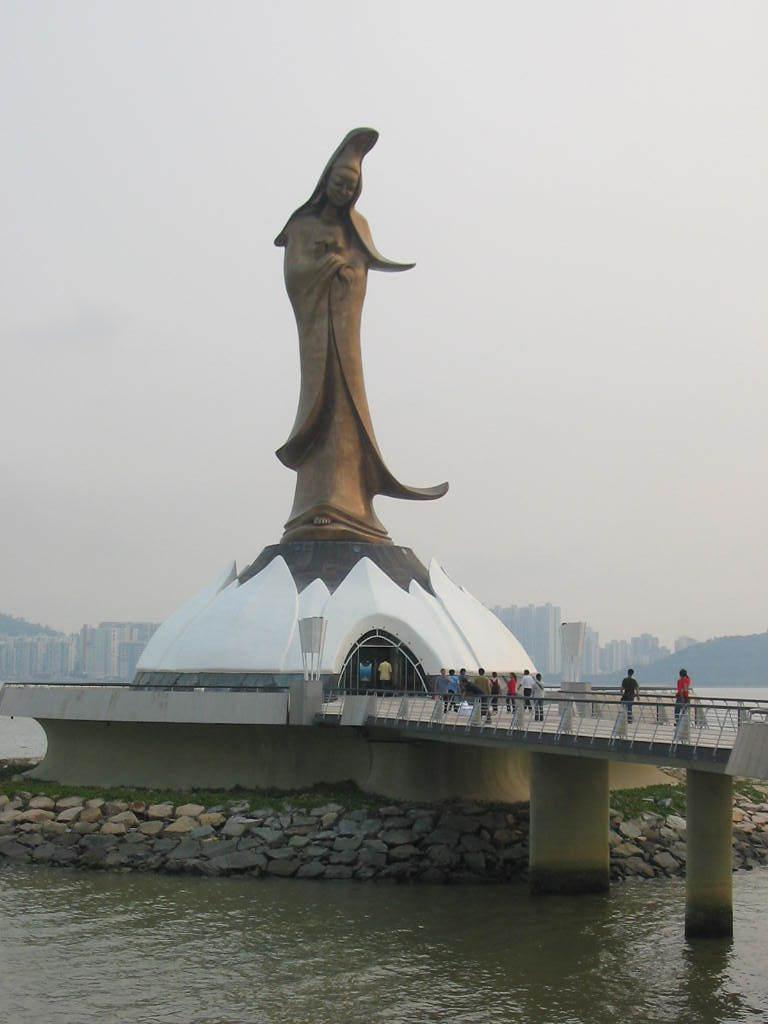What is the primary element present in the image? There is water in the image. What other objects can be seen in the image? There are rocks, a statue, people on a bridge, and buildings in the background. Can you describe the statue in the image? The statue is a prominent feature in the image, but its specific details are not mentioned in the facts. What type of structures are visible in the background? There are buildings in the background of the image. What type of fruit is being harvested by the people on the bridge in the image? There is no fruit present in the image, nor are there any people harvesting anything on the bridge. 